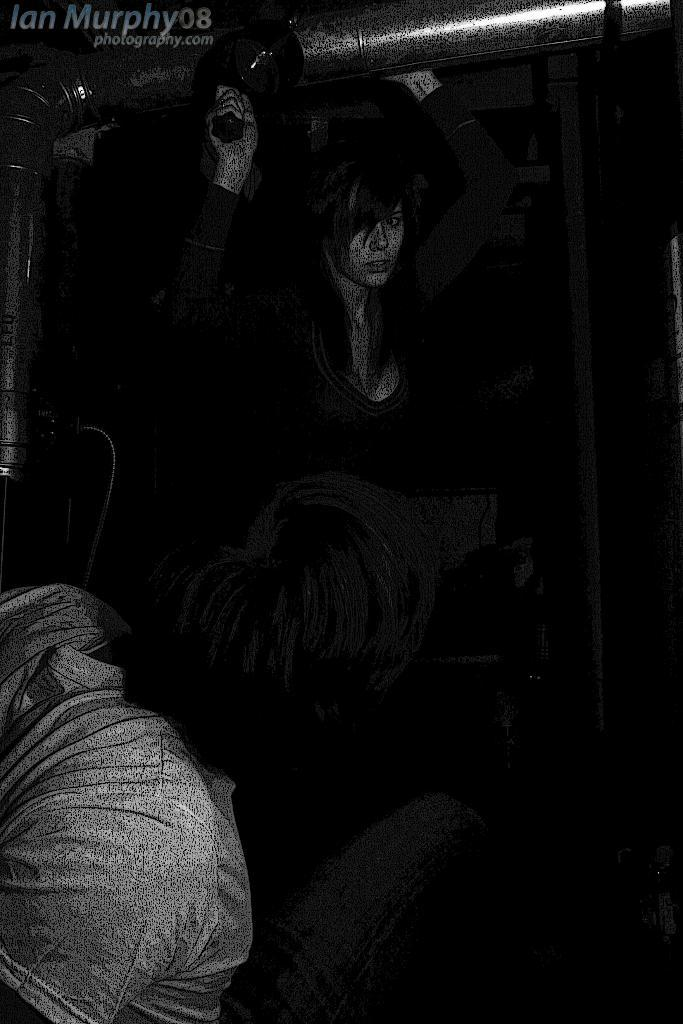What can be seen in the image besides the woman? There is a poster in the image. What is the woman holding in her hand? The woman is holding a pipe in one hand. What is the woman holding in her other hand? The woman is holding something in her other hand, but it is not specified in the facts. How many people are standing near the woman? There are two people standing near the woman. How would you describe the lighting in the image? The scene is set in a dark environment. What type of celery is the woman eating in the image? There is no celery present in the image. How does the woman feel about the afterthought of the poster design? The facts do not mention any feelings or opinions about the poster design, nor is there any reference to an afterthought. 